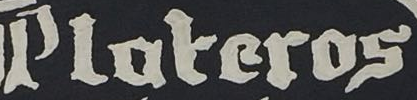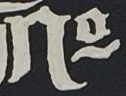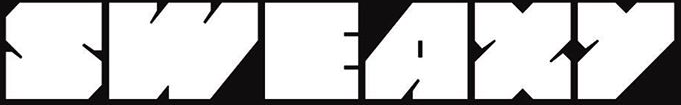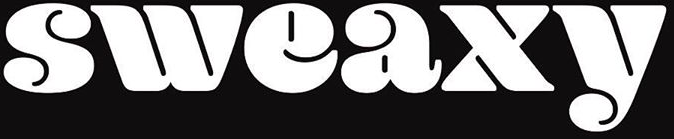What words can you see in these images in sequence, separated by a semicolon? Ploteros; No; SWEAXY; sweaxy 